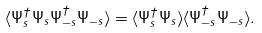<formula> <loc_0><loc_0><loc_500><loc_500>\langle \Psi ^ { \dagger } _ { s } \Psi _ { s } \Psi ^ { \dagger } _ { - s } \Psi _ { - s } \rangle = \langle \Psi ^ { \dagger } _ { s } \Psi _ { s } \rangle \langle \Psi ^ { \dagger } _ { - s } \Psi _ { - s } \rangle .</formula> 